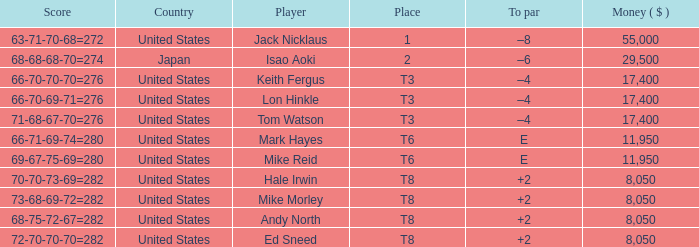What player has money larger than 11,950 and is placed in t8 and has the score of 73-68-69-72=282? None. 